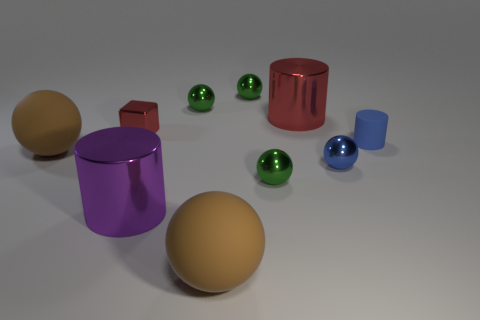There is a small object on the right side of the blue shiny thing; what is its color?
Provide a succinct answer. Blue. Is the shape of the blue matte object the same as the big red thing?
Your answer should be compact. Yes. What is the color of the rubber thing that is in front of the blue rubber thing and right of the red metallic block?
Provide a short and direct response. Brown. There is a matte cylinder that is to the right of the purple cylinder; is it the same size as the brown ball that is in front of the tiny blue metal ball?
Offer a terse response. No. How many things are either shiny balls behind the tiny red block or small brown metallic blocks?
Ensure brevity in your answer.  2. What material is the big purple cylinder?
Your answer should be compact. Metal. Is the size of the blue rubber thing the same as the red shiny cube?
Your response must be concise. Yes. What number of blocks are brown matte objects or matte objects?
Provide a succinct answer. 0. What color is the big cylinder left of the brown thing that is in front of the tiny blue shiny thing?
Give a very brief answer. Purple. Are there fewer shiny spheres in front of the small cube than large objects that are in front of the big red cylinder?
Your answer should be very brief. Yes. 